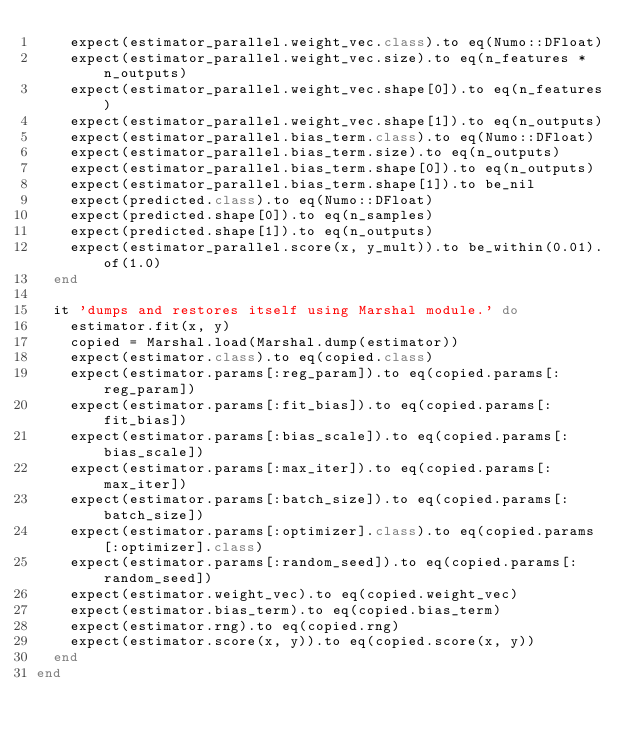<code> <loc_0><loc_0><loc_500><loc_500><_Ruby_>    expect(estimator_parallel.weight_vec.class).to eq(Numo::DFloat)
    expect(estimator_parallel.weight_vec.size).to eq(n_features * n_outputs)
    expect(estimator_parallel.weight_vec.shape[0]).to eq(n_features)
    expect(estimator_parallel.weight_vec.shape[1]).to eq(n_outputs)
    expect(estimator_parallel.bias_term.class).to eq(Numo::DFloat)
    expect(estimator_parallel.bias_term.size).to eq(n_outputs)
    expect(estimator_parallel.bias_term.shape[0]).to eq(n_outputs)
    expect(estimator_parallel.bias_term.shape[1]).to be_nil
    expect(predicted.class).to eq(Numo::DFloat)
    expect(predicted.shape[0]).to eq(n_samples)
    expect(predicted.shape[1]).to eq(n_outputs)
    expect(estimator_parallel.score(x, y_mult)).to be_within(0.01).of(1.0)
  end

  it 'dumps and restores itself using Marshal module.' do
    estimator.fit(x, y)
    copied = Marshal.load(Marshal.dump(estimator))
    expect(estimator.class).to eq(copied.class)
    expect(estimator.params[:reg_param]).to eq(copied.params[:reg_param])
    expect(estimator.params[:fit_bias]).to eq(copied.params[:fit_bias])
    expect(estimator.params[:bias_scale]).to eq(copied.params[:bias_scale])
    expect(estimator.params[:max_iter]).to eq(copied.params[:max_iter])
    expect(estimator.params[:batch_size]).to eq(copied.params[:batch_size])
    expect(estimator.params[:optimizer].class).to eq(copied.params[:optimizer].class)
    expect(estimator.params[:random_seed]).to eq(copied.params[:random_seed])
    expect(estimator.weight_vec).to eq(copied.weight_vec)
    expect(estimator.bias_term).to eq(copied.bias_term)
    expect(estimator.rng).to eq(copied.rng)
    expect(estimator.score(x, y)).to eq(copied.score(x, y))
  end
end
</code> 